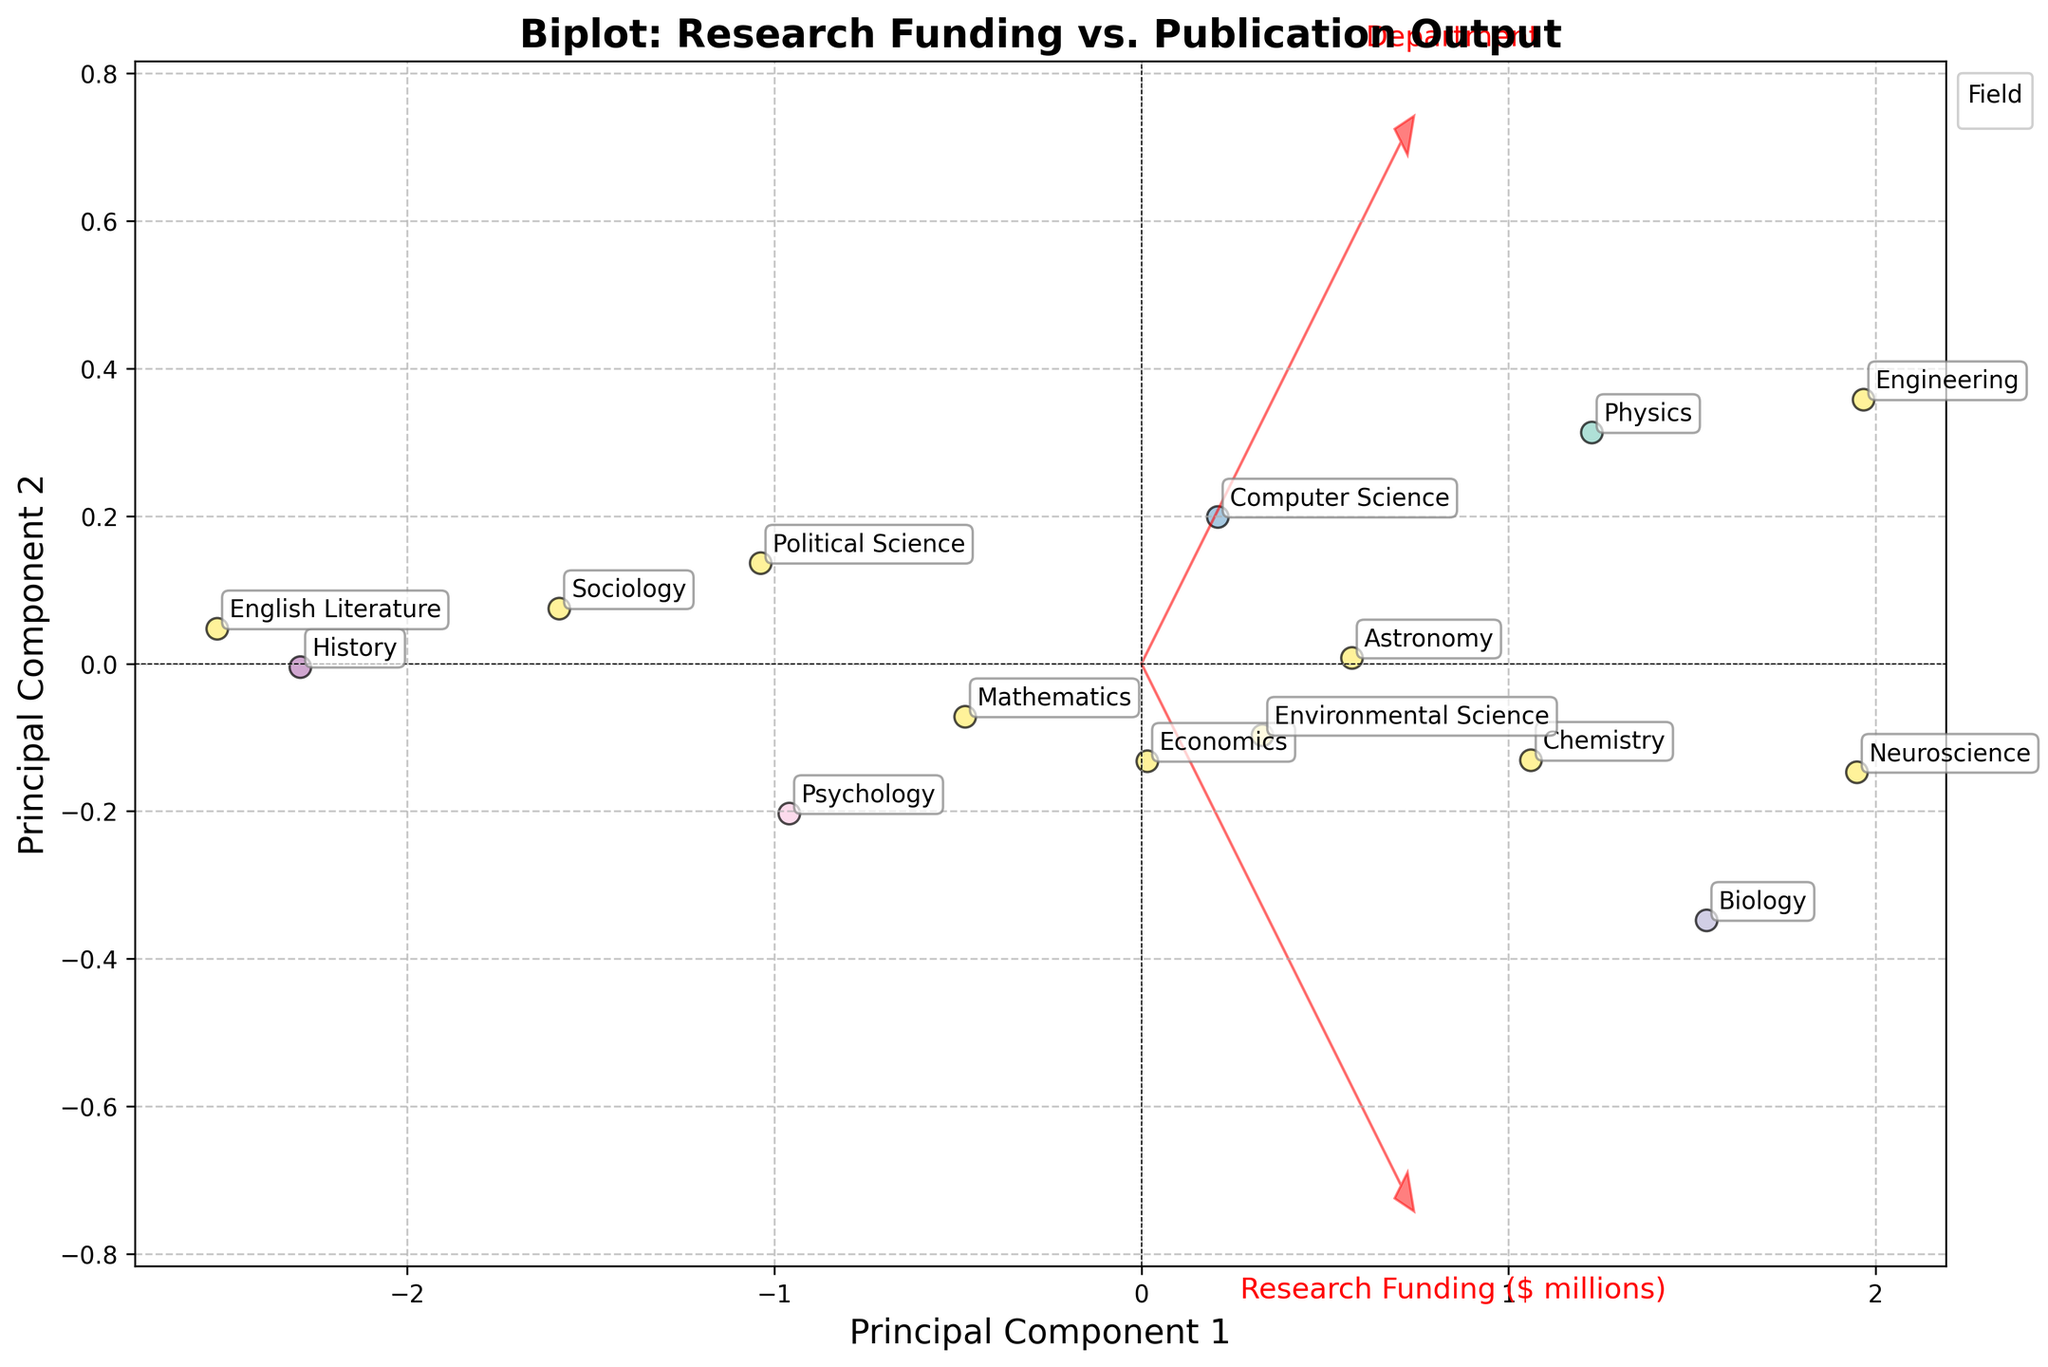What is the title of the biplot? The title is usually located at the top of the plot and is meant to give a brief description of what the plot represents. Here, the title is "Biplot: Research Funding vs. Publication Output".
Answer: Biplot: Research Funding vs. Publication Output How many academic departments are represented in the biplot? By counting the individual scatter points labeled with department names, we can identify a total of 15 data points, each representing one department.
Answer: 15 Which field has the highest number of publications and which department does it belong to? By examining the biplot, we look for the data point furthest along the publications dimension. The highest number of publications corresponds to the "Neuroscience" department in the "Life Sciences" field.
Answer: Neuroscience, Life Sciences Which department has the least research funding and what is its corresponding field? We look for the data point that is least along the research funding dimension. This department is "English Literature" in the "Humanities" field.
Answer: English Literature, Humanities Between Physics and Astronomy, which department has more publications? By checking the positions of the "Physics" and "Astronomy" data points along the publications dimension, we see that Physics has 78 publications whereas Astronomy has 73 publications.
Answer: Physics Compare the research funding between the departments of Sociology and Psychology. Which has more funding and by how much? By locating the positions of "Sociology" and "Psychology" on the research funding axis and reading their values, Sociology has $1.7 million and Psychology has $2.1 million in research funding. The difference is $2.1M - $1.7M = $0.4M.
Answer: Psychology by $0.4M In which quadrant is the department of Mathematics located? By identifying the position of "Mathematics" on the biplot, we determine its coordinates in terms of principal components. It is in the upper-left quadrant (negative on PC1, positive on PC2).
Answer: Upper-left Which two vectors represent the features in the biplot, and in what direction do they point? The vectors in the biplot represent the original variables "Research Funding" and "Publications". They have arrows starting from (0,0) and directionally aligned according to the first two principal components.
Answer: Research Funding and Publications, towards positive directions of PC1 and PC2 How is the field of Humanities represented in terms of the number of data points and color in the biplot? The "Humanities" field is represented by two data points, "History" and "English Literature," and usually assigned a unique color, visible in the legend and on the scatter plot.
Answer: 2 data points, unique color 